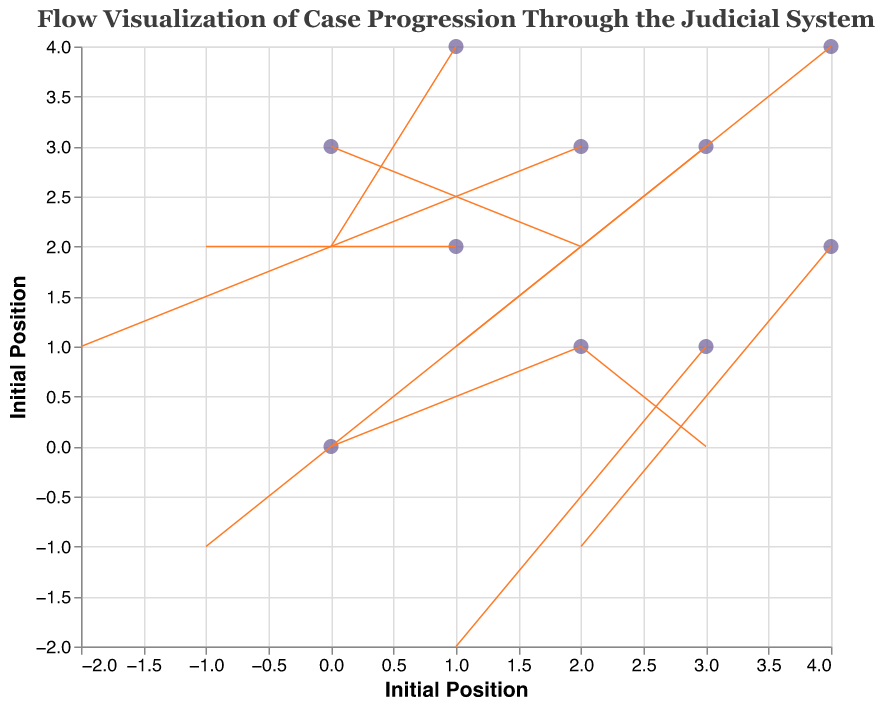What is the title of the chart? The title of the chart can typically be found at the top center of the figure. Here, it states "Flow Visualization of Case Progression Through the Judicial System."
Answer: Flow Visualization of Case Progression Through the Judicial System What color are the points representing each case type? To identify the color of the points, you simply observe their color in the visualization. They are filled; the description indicates they are "#6b5b95." Looking at the figure, this is a shade of purple.
Answer: Purple Which type of case starts at the coordinates (2, 1)? By examining the data points and matching the coordinates (2, 1) to their labels, we see that "Tort Lawsuit" starts at this position.
Answer: Tort Lawsuit What is the general direction of the flow for the Family Law Case? The flow direction is indicated by the 'u' and 'v' values at the coordinates (4, 2). 'u' is 2 and 'v' is -1, so the direction is towards the right and downward.
Answer: Right and Downward How many cases start at coordinates where x = 3? To determine this, you count all entries in the data where 'x' value equals 3. There are three such cases: Contract Dispute (3, 3), Employment Discrimination (3, 1), and Environmental Law Case (3, 1).
Answer: 3 Which case has the largest horizontal movement and what is its magnitude? Horizontal movement is determined by the absolute value of 'u'. The largest 'u' is 3 for Tort Lawsuit, starting at (2, 1).
Answer: Tort Lawsuit, 3 Compare the vertical movement of the Constitutional Challenge and Employment Discrimination cases. Which one moves more vertically? The vertical movement is determined by the absolute value of 'v'. Constitutional Challenge has 'v' of 2 and Employment Discrimination has 'v' of -2. Both move the same distance vertically.
Answer: Same What is the net movement direction for the Environmental Law Case? Starting at (2, 3), Environmental Law Case moves with 'u' of -2 (left) and 'v' of 1 (up). Combining these directions, the net movement is to the left and upward.
Answer: Left and Upward Which case ends up at coordinates (5, 1)? By summing starting coordinates with respective 'u' and 'v' values, and checking which ends at (5, 1), we find the Family Law Case (4, 2) + (2, -1) ends here.
Answer: Family Law Case What is the initial position of the Bankruptcy Petition case? The initial position of each case is given by its 'x, y' coordinates. For Bankruptcy Petition, these are (4, 4).
Answer: (4, 4) 